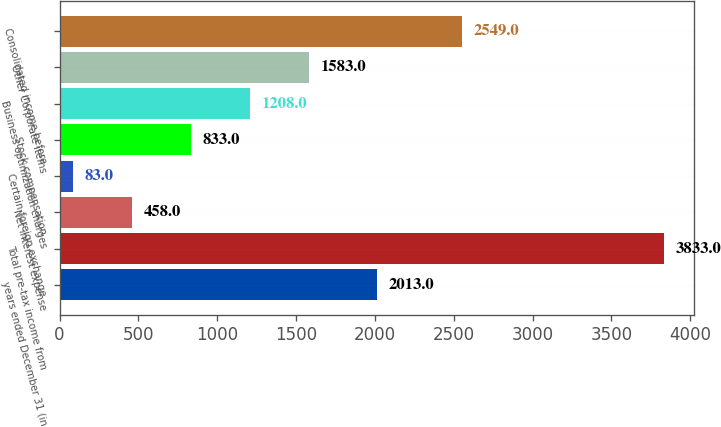Convert chart to OTSL. <chart><loc_0><loc_0><loc_500><loc_500><bar_chart><fcel>years ended December 31 (in<fcel>Total pre-tax income from<fcel>Net interest expense<fcel>Certain foreign exchange<fcel>Stock compensation<fcel>Business optimization charges<fcel>Other Corporate items<fcel>Consolidated income before<nl><fcel>2013<fcel>3833<fcel>458<fcel>83<fcel>833<fcel>1208<fcel>1583<fcel>2549<nl></chart> 